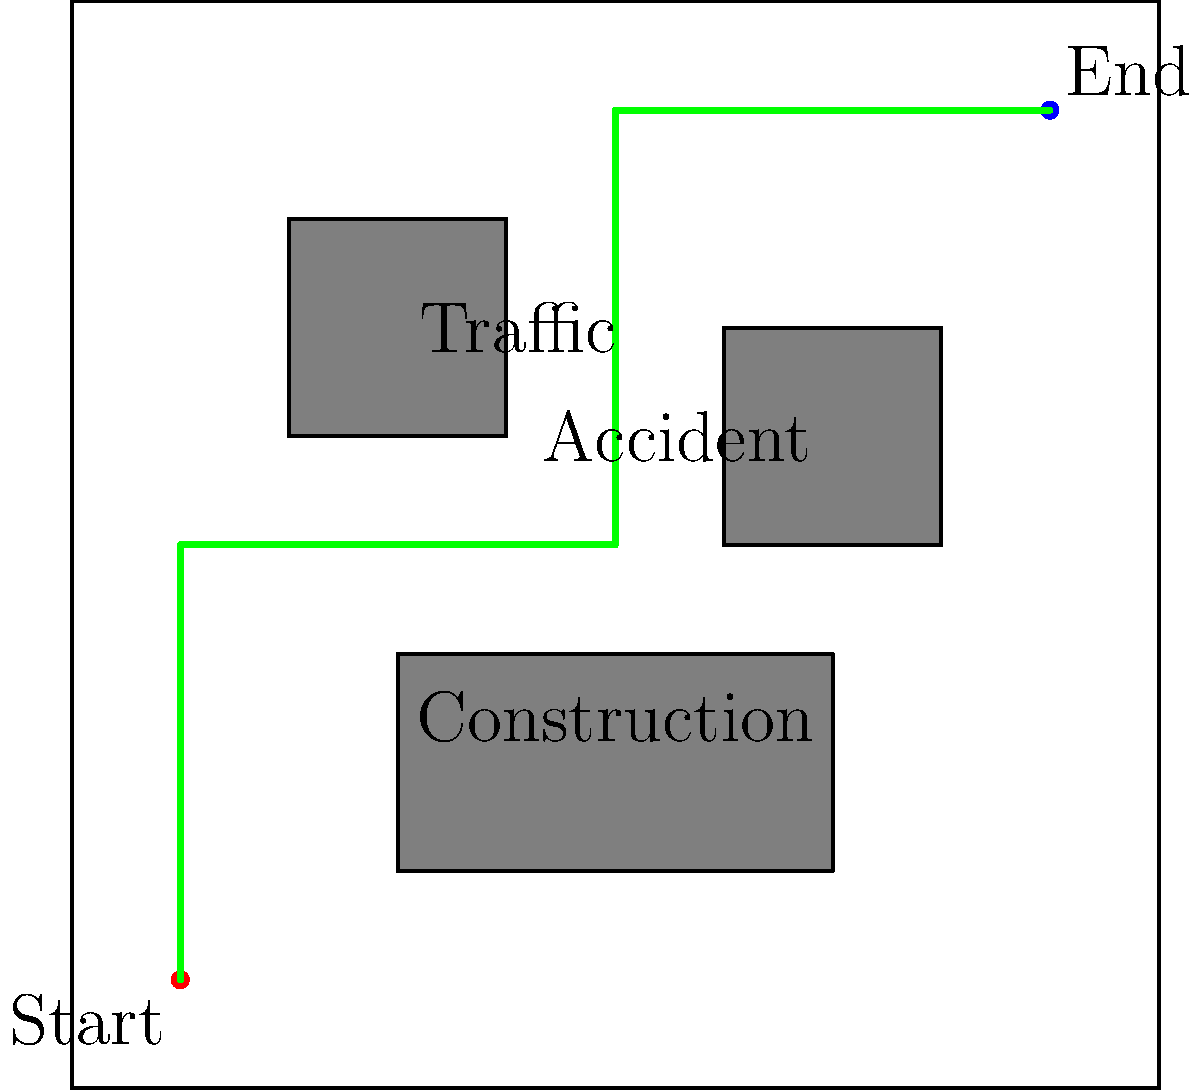As a courier, you need to deliver a package from the Start point to the End point in the city layout shown above. The direct distance between Start and End is 80 blocks, but there are obstacles along the way. Given that you can travel at an average speed of 2 blocks per minute in clear areas and 1 block per minute through obstacle areas, estimate the total delivery time in minutes. Round your answer to the nearest whole number. Let's break this down step-by-step:

1. Analyze the route:
   - The green line shows the optimal route avoiding obstacles.
   - The route goes around the construction and accident areas but passes through the traffic area.

2. Calculate the total distance:
   - From Start to traffic area: 40 blocks (10 right + 30 up)
   - Through traffic area: 20 blocks
   - From traffic area to End: 60 blocks (40 right + 20 up)
   - Total distance = 40 + 20 + 60 = 120 blocks

3. Calculate time in clear areas:
   - Clear distance = 120 - 20 = 100 blocks (subtracting traffic area)
   - Time in clear areas = 100 blocks ÷ 2 blocks/minute = 50 minutes

4. Calculate time in obstacle area (traffic):
   - Obstacle distance = 20 blocks
   - Time in obstacle area = 20 blocks ÷ 1 block/minute = 20 minutes

5. Sum up total time:
   - Total time = Time in clear areas + Time in obstacle area
   - Total time = 50 minutes + 20 minutes = 70 minutes

Therefore, the estimated delivery time is 70 minutes.
Answer: 70 minutes 